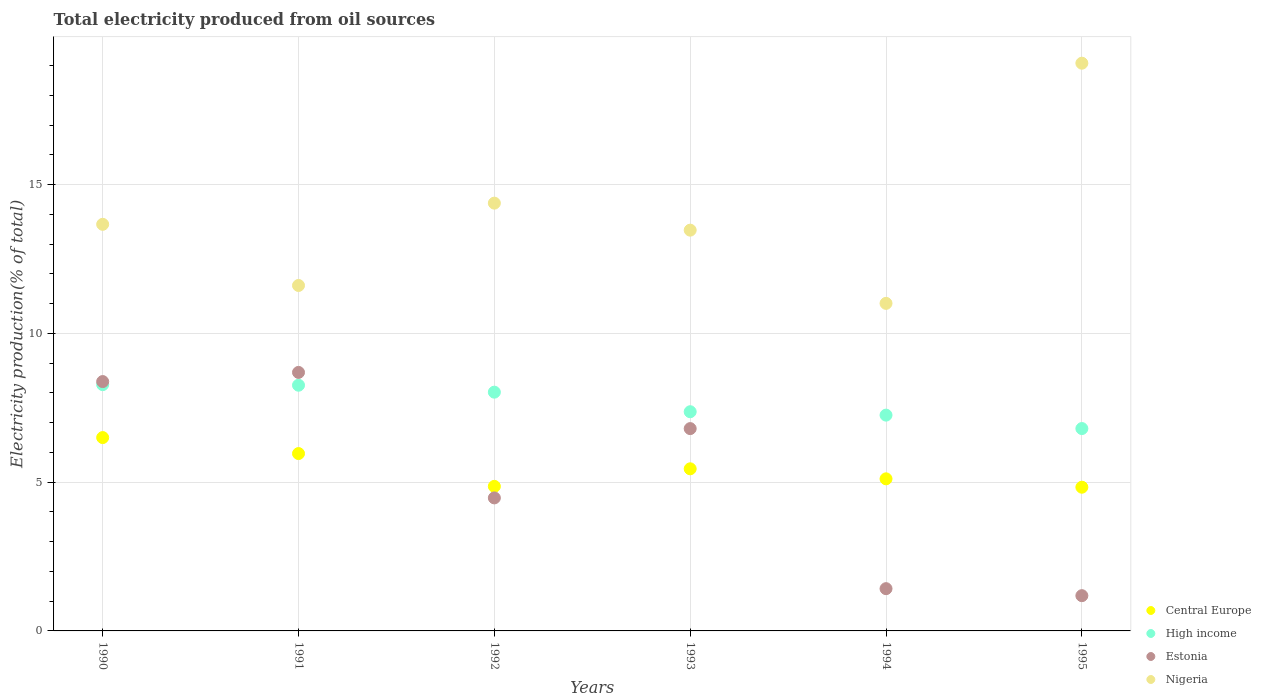Is the number of dotlines equal to the number of legend labels?
Make the answer very short. Yes. What is the total electricity produced in Estonia in 1993?
Make the answer very short. 6.8. Across all years, what is the maximum total electricity produced in Estonia?
Make the answer very short. 8.69. Across all years, what is the minimum total electricity produced in Nigeria?
Your response must be concise. 11.01. In which year was the total electricity produced in High income maximum?
Make the answer very short. 1990. What is the total total electricity produced in Central Europe in the graph?
Offer a very short reply. 32.71. What is the difference between the total electricity produced in Nigeria in 1992 and that in 1993?
Provide a succinct answer. 0.91. What is the difference between the total electricity produced in Estonia in 1992 and the total electricity produced in Nigeria in 1990?
Provide a short and direct response. -9.2. What is the average total electricity produced in High income per year?
Offer a terse response. 7.66. In the year 1993, what is the difference between the total electricity produced in High income and total electricity produced in Central Europe?
Offer a terse response. 1.92. What is the ratio of the total electricity produced in Estonia in 1992 to that in 1993?
Give a very brief answer. 0.66. Is the total electricity produced in Central Europe in 1992 less than that in 1995?
Offer a very short reply. No. What is the difference between the highest and the second highest total electricity produced in High income?
Offer a very short reply. 0.02. What is the difference between the highest and the lowest total electricity produced in High income?
Make the answer very short. 1.48. In how many years, is the total electricity produced in High income greater than the average total electricity produced in High income taken over all years?
Provide a succinct answer. 3. Is the sum of the total electricity produced in Central Europe in 1993 and 1995 greater than the maximum total electricity produced in High income across all years?
Provide a succinct answer. Yes. Does the total electricity produced in Estonia monotonically increase over the years?
Offer a terse response. No. How many dotlines are there?
Your answer should be very brief. 4. What is the difference between two consecutive major ticks on the Y-axis?
Provide a succinct answer. 5. Does the graph contain any zero values?
Your answer should be very brief. No. Where does the legend appear in the graph?
Provide a succinct answer. Bottom right. How many legend labels are there?
Offer a very short reply. 4. What is the title of the graph?
Provide a short and direct response. Total electricity produced from oil sources. What is the label or title of the X-axis?
Your response must be concise. Years. What is the Electricity production(% of total) in Central Europe in 1990?
Make the answer very short. 6.5. What is the Electricity production(% of total) in High income in 1990?
Your answer should be compact. 8.28. What is the Electricity production(% of total) in Estonia in 1990?
Offer a very short reply. 8.38. What is the Electricity production(% of total) of Nigeria in 1990?
Ensure brevity in your answer.  13.67. What is the Electricity production(% of total) in Central Europe in 1991?
Provide a succinct answer. 5.96. What is the Electricity production(% of total) of High income in 1991?
Your answer should be compact. 8.26. What is the Electricity production(% of total) of Estonia in 1991?
Give a very brief answer. 8.69. What is the Electricity production(% of total) of Nigeria in 1991?
Your response must be concise. 11.61. What is the Electricity production(% of total) in Central Europe in 1992?
Give a very brief answer. 4.86. What is the Electricity production(% of total) of High income in 1992?
Offer a very short reply. 8.03. What is the Electricity production(% of total) of Estonia in 1992?
Provide a succinct answer. 4.47. What is the Electricity production(% of total) of Nigeria in 1992?
Offer a terse response. 14.38. What is the Electricity production(% of total) in Central Europe in 1993?
Ensure brevity in your answer.  5.45. What is the Electricity production(% of total) of High income in 1993?
Offer a very short reply. 7.37. What is the Electricity production(% of total) of Estonia in 1993?
Keep it short and to the point. 6.8. What is the Electricity production(% of total) of Nigeria in 1993?
Keep it short and to the point. 13.47. What is the Electricity production(% of total) in Central Europe in 1994?
Keep it short and to the point. 5.11. What is the Electricity production(% of total) of High income in 1994?
Make the answer very short. 7.25. What is the Electricity production(% of total) in Estonia in 1994?
Your answer should be compact. 1.42. What is the Electricity production(% of total) in Nigeria in 1994?
Your answer should be very brief. 11.01. What is the Electricity production(% of total) in Central Europe in 1995?
Offer a terse response. 4.83. What is the Electricity production(% of total) in High income in 1995?
Your response must be concise. 6.8. What is the Electricity production(% of total) in Estonia in 1995?
Make the answer very short. 1.18. What is the Electricity production(% of total) of Nigeria in 1995?
Your answer should be compact. 19.08. Across all years, what is the maximum Electricity production(% of total) of Central Europe?
Give a very brief answer. 6.5. Across all years, what is the maximum Electricity production(% of total) in High income?
Offer a terse response. 8.28. Across all years, what is the maximum Electricity production(% of total) of Estonia?
Give a very brief answer. 8.69. Across all years, what is the maximum Electricity production(% of total) in Nigeria?
Your answer should be very brief. 19.08. Across all years, what is the minimum Electricity production(% of total) in Central Europe?
Offer a very short reply. 4.83. Across all years, what is the minimum Electricity production(% of total) in High income?
Ensure brevity in your answer.  6.8. Across all years, what is the minimum Electricity production(% of total) of Estonia?
Your response must be concise. 1.18. Across all years, what is the minimum Electricity production(% of total) of Nigeria?
Offer a terse response. 11.01. What is the total Electricity production(% of total) in Central Europe in the graph?
Offer a very short reply. 32.71. What is the total Electricity production(% of total) in High income in the graph?
Offer a very short reply. 45.99. What is the total Electricity production(% of total) of Estonia in the graph?
Ensure brevity in your answer.  30.95. What is the total Electricity production(% of total) of Nigeria in the graph?
Provide a succinct answer. 83.22. What is the difference between the Electricity production(% of total) of Central Europe in 1990 and that in 1991?
Keep it short and to the point. 0.54. What is the difference between the Electricity production(% of total) in High income in 1990 and that in 1991?
Offer a terse response. 0.02. What is the difference between the Electricity production(% of total) of Estonia in 1990 and that in 1991?
Your response must be concise. -0.31. What is the difference between the Electricity production(% of total) in Nigeria in 1990 and that in 1991?
Provide a succinct answer. 2.06. What is the difference between the Electricity production(% of total) in Central Europe in 1990 and that in 1992?
Keep it short and to the point. 1.64. What is the difference between the Electricity production(% of total) in High income in 1990 and that in 1992?
Your answer should be compact. 0.25. What is the difference between the Electricity production(% of total) in Estonia in 1990 and that in 1992?
Provide a short and direct response. 3.91. What is the difference between the Electricity production(% of total) in Nigeria in 1990 and that in 1992?
Keep it short and to the point. -0.71. What is the difference between the Electricity production(% of total) of Central Europe in 1990 and that in 1993?
Ensure brevity in your answer.  1.05. What is the difference between the Electricity production(% of total) in High income in 1990 and that in 1993?
Make the answer very short. 0.91. What is the difference between the Electricity production(% of total) of Estonia in 1990 and that in 1993?
Your response must be concise. 1.58. What is the difference between the Electricity production(% of total) of Nigeria in 1990 and that in 1993?
Your response must be concise. 0.2. What is the difference between the Electricity production(% of total) of Central Europe in 1990 and that in 1994?
Keep it short and to the point. 1.39. What is the difference between the Electricity production(% of total) of High income in 1990 and that in 1994?
Offer a very short reply. 1.03. What is the difference between the Electricity production(% of total) of Estonia in 1990 and that in 1994?
Ensure brevity in your answer.  6.96. What is the difference between the Electricity production(% of total) of Nigeria in 1990 and that in 1994?
Offer a very short reply. 2.66. What is the difference between the Electricity production(% of total) of Central Europe in 1990 and that in 1995?
Provide a succinct answer. 1.67. What is the difference between the Electricity production(% of total) of High income in 1990 and that in 1995?
Offer a very short reply. 1.48. What is the difference between the Electricity production(% of total) of Estonia in 1990 and that in 1995?
Provide a succinct answer. 7.2. What is the difference between the Electricity production(% of total) of Nigeria in 1990 and that in 1995?
Keep it short and to the point. -5.42. What is the difference between the Electricity production(% of total) of Central Europe in 1991 and that in 1992?
Provide a succinct answer. 1.1. What is the difference between the Electricity production(% of total) in High income in 1991 and that in 1992?
Provide a succinct answer. 0.23. What is the difference between the Electricity production(% of total) of Estonia in 1991 and that in 1992?
Your answer should be compact. 4.22. What is the difference between the Electricity production(% of total) of Nigeria in 1991 and that in 1992?
Make the answer very short. -2.77. What is the difference between the Electricity production(% of total) of Central Europe in 1991 and that in 1993?
Provide a short and direct response. 0.51. What is the difference between the Electricity production(% of total) in High income in 1991 and that in 1993?
Make the answer very short. 0.89. What is the difference between the Electricity production(% of total) of Estonia in 1991 and that in 1993?
Your answer should be compact. 1.89. What is the difference between the Electricity production(% of total) of Nigeria in 1991 and that in 1993?
Ensure brevity in your answer.  -1.86. What is the difference between the Electricity production(% of total) of Central Europe in 1991 and that in 1994?
Ensure brevity in your answer.  0.85. What is the difference between the Electricity production(% of total) of High income in 1991 and that in 1994?
Your response must be concise. 1.01. What is the difference between the Electricity production(% of total) of Estonia in 1991 and that in 1994?
Your answer should be very brief. 7.27. What is the difference between the Electricity production(% of total) of Nigeria in 1991 and that in 1994?
Offer a very short reply. 0.6. What is the difference between the Electricity production(% of total) of Central Europe in 1991 and that in 1995?
Provide a short and direct response. 1.13. What is the difference between the Electricity production(% of total) in High income in 1991 and that in 1995?
Your response must be concise. 1.46. What is the difference between the Electricity production(% of total) in Estonia in 1991 and that in 1995?
Ensure brevity in your answer.  7.5. What is the difference between the Electricity production(% of total) of Nigeria in 1991 and that in 1995?
Provide a succinct answer. -7.47. What is the difference between the Electricity production(% of total) of Central Europe in 1992 and that in 1993?
Ensure brevity in your answer.  -0.59. What is the difference between the Electricity production(% of total) of High income in 1992 and that in 1993?
Offer a terse response. 0.66. What is the difference between the Electricity production(% of total) in Estonia in 1992 and that in 1993?
Your answer should be compact. -2.33. What is the difference between the Electricity production(% of total) of Nigeria in 1992 and that in 1993?
Offer a very short reply. 0.91. What is the difference between the Electricity production(% of total) of Central Europe in 1992 and that in 1994?
Provide a succinct answer. -0.25. What is the difference between the Electricity production(% of total) in High income in 1992 and that in 1994?
Give a very brief answer. 0.77. What is the difference between the Electricity production(% of total) in Estonia in 1992 and that in 1994?
Keep it short and to the point. 3.05. What is the difference between the Electricity production(% of total) in Nigeria in 1992 and that in 1994?
Your answer should be compact. 3.37. What is the difference between the Electricity production(% of total) in Central Europe in 1992 and that in 1995?
Make the answer very short. 0.03. What is the difference between the Electricity production(% of total) in High income in 1992 and that in 1995?
Give a very brief answer. 1.22. What is the difference between the Electricity production(% of total) in Estonia in 1992 and that in 1995?
Your response must be concise. 3.29. What is the difference between the Electricity production(% of total) of Nigeria in 1992 and that in 1995?
Provide a succinct answer. -4.7. What is the difference between the Electricity production(% of total) in Central Europe in 1993 and that in 1994?
Provide a short and direct response. 0.34. What is the difference between the Electricity production(% of total) in High income in 1993 and that in 1994?
Provide a short and direct response. 0.11. What is the difference between the Electricity production(% of total) of Estonia in 1993 and that in 1994?
Your answer should be very brief. 5.38. What is the difference between the Electricity production(% of total) in Nigeria in 1993 and that in 1994?
Make the answer very short. 2.46. What is the difference between the Electricity production(% of total) in Central Europe in 1993 and that in 1995?
Ensure brevity in your answer.  0.62. What is the difference between the Electricity production(% of total) in High income in 1993 and that in 1995?
Keep it short and to the point. 0.57. What is the difference between the Electricity production(% of total) in Estonia in 1993 and that in 1995?
Make the answer very short. 5.62. What is the difference between the Electricity production(% of total) in Nigeria in 1993 and that in 1995?
Provide a short and direct response. -5.61. What is the difference between the Electricity production(% of total) in Central Europe in 1994 and that in 1995?
Your answer should be very brief. 0.28. What is the difference between the Electricity production(% of total) in High income in 1994 and that in 1995?
Your response must be concise. 0.45. What is the difference between the Electricity production(% of total) of Estonia in 1994 and that in 1995?
Keep it short and to the point. 0.24. What is the difference between the Electricity production(% of total) of Nigeria in 1994 and that in 1995?
Ensure brevity in your answer.  -8.07. What is the difference between the Electricity production(% of total) in Central Europe in 1990 and the Electricity production(% of total) in High income in 1991?
Provide a succinct answer. -1.76. What is the difference between the Electricity production(% of total) of Central Europe in 1990 and the Electricity production(% of total) of Estonia in 1991?
Ensure brevity in your answer.  -2.19. What is the difference between the Electricity production(% of total) in Central Europe in 1990 and the Electricity production(% of total) in Nigeria in 1991?
Your answer should be compact. -5.11. What is the difference between the Electricity production(% of total) in High income in 1990 and the Electricity production(% of total) in Estonia in 1991?
Your response must be concise. -0.41. What is the difference between the Electricity production(% of total) in High income in 1990 and the Electricity production(% of total) in Nigeria in 1991?
Your response must be concise. -3.33. What is the difference between the Electricity production(% of total) in Estonia in 1990 and the Electricity production(% of total) in Nigeria in 1991?
Provide a succinct answer. -3.23. What is the difference between the Electricity production(% of total) in Central Europe in 1990 and the Electricity production(% of total) in High income in 1992?
Your answer should be compact. -1.53. What is the difference between the Electricity production(% of total) of Central Europe in 1990 and the Electricity production(% of total) of Estonia in 1992?
Offer a very short reply. 2.03. What is the difference between the Electricity production(% of total) in Central Europe in 1990 and the Electricity production(% of total) in Nigeria in 1992?
Give a very brief answer. -7.88. What is the difference between the Electricity production(% of total) in High income in 1990 and the Electricity production(% of total) in Estonia in 1992?
Keep it short and to the point. 3.81. What is the difference between the Electricity production(% of total) of High income in 1990 and the Electricity production(% of total) of Nigeria in 1992?
Your response must be concise. -6.1. What is the difference between the Electricity production(% of total) of Estonia in 1990 and the Electricity production(% of total) of Nigeria in 1992?
Make the answer very short. -6. What is the difference between the Electricity production(% of total) of Central Europe in 1990 and the Electricity production(% of total) of High income in 1993?
Offer a very short reply. -0.87. What is the difference between the Electricity production(% of total) of Central Europe in 1990 and the Electricity production(% of total) of Estonia in 1993?
Offer a very short reply. -0.3. What is the difference between the Electricity production(% of total) in Central Europe in 1990 and the Electricity production(% of total) in Nigeria in 1993?
Give a very brief answer. -6.97. What is the difference between the Electricity production(% of total) in High income in 1990 and the Electricity production(% of total) in Estonia in 1993?
Your response must be concise. 1.48. What is the difference between the Electricity production(% of total) of High income in 1990 and the Electricity production(% of total) of Nigeria in 1993?
Provide a short and direct response. -5.19. What is the difference between the Electricity production(% of total) in Estonia in 1990 and the Electricity production(% of total) in Nigeria in 1993?
Make the answer very short. -5.09. What is the difference between the Electricity production(% of total) in Central Europe in 1990 and the Electricity production(% of total) in High income in 1994?
Your answer should be very brief. -0.75. What is the difference between the Electricity production(% of total) in Central Europe in 1990 and the Electricity production(% of total) in Estonia in 1994?
Provide a short and direct response. 5.08. What is the difference between the Electricity production(% of total) in Central Europe in 1990 and the Electricity production(% of total) in Nigeria in 1994?
Make the answer very short. -4.51. What is the difference between the Electricity production(% of total) of High income in 1990 and the Electricity production(% of total) of Estonia in 1994?
Provide a succinct answer. 6.86. What is the difference between the Electricity production(% of total) of High income in 1990 and the Electricity production(% of total) of Nigeria in 1994?
Offer a very short reply. -2.73. What is the difference between the Electricity production(% of total) of Estonia in 1990 and the Electricity production(% of total) of Nigeria in 1994?
Offer a very short reply. -2.63. What is the difference between the Electricity production(% of total) of Central Europe in 1990 and the Electricity production(% of total) of High income in 1995?
Provide a short and direct response. -0.3. What is the difference between the Electricity production(% of total) in Central Europe in 1990 and the Electricity production(% of total) in Estonia in 1995?
Give a very brief answer. 5.31. What is the difference between the Electricity production(% of total) of Central Europe in 1990 and the Electricity production(% of total) of Nigeria in 1995?
Give a very brief answer. -12.58. What is the difference between the Electricity production(% of total) in High income in 1990 and the Electricity production(% of total) in Estonia in 1995?
Offer a very short reply. 7.09. What is the difference between the Electricity production(% of total) of High income in 1990 and the Electricity production(% of total) of Nigeria in 1995?
Your answer should be very brief. -10.8. What is the difference between the Electricity production(% of total) in Estonia in 1990 and the Electricity production(% of total) in Nigeria in 1995?
Offer a very short reply. -10.7. What is the difference between the Electricity production(% of total) in Central Europe in 1991 and the Electricity production(% of total) in High income in 1992?
Keep it short and to the point. -2.06. What is the difference between the Electricity production(% of total) of Central Europe in 1991 and the Electricity production(% of total) of Estonia in 1992?
Offer a very short reply. 1.49. What is the difference between the Electricity production(% of total) of Central Europe in 1991 and the Electricity production(% of total) of Nigeria in 1992?
Offer a terse response. -8.42. What is the difference between the Electricity production(% of total) of High income in 1991 and the Electricity production(% of total) of Estonia in 1992?
Provide a short and direct response. 3.79. What is the difference between the Electricity production(% of total) in High income in 1991 and the Electricity production(% of total) in Nigeria in 1992?
Your response must be concise. -6.12. What is the difference between the Electricity production(% of total) in Estonia in 1991 and the Electricity production(% of total) in Nigeria in 1992?
Offer a terse response. -5.69. What is the difference between the Electricity production(% of total) of Central Europe in 1991 and the Electricity production(% of total) of High income in 1993?
Make the answer very short. -1.41. What is the difference between the Electricity production(% of total) in Central Europe in 1991 and the Electricity production(% of total) in Estonia in 1993?
Provide a short and direct response. -0.84. What is the difference between the Electricity production(% of total) of Central Europe in 1991 and the Electricity production(% of total) of Nigeria in 1993?
Provide a succinct answer. -7.51. What is the difference between the Electricity production(% of total) in High income in 1991 and the Electricity production(% of total) in Estonia in 1993?
Your answer should be very brief. 1.46. What is the difference between the Electricity production(% of total) of High income in 1991 and the Electricity production(% of total) of Nigeria in 1993?
Provide a succinct answer. -5.21. What is the difference between the Electricity production(% of total) of Estonia in 1991 and the Electricity production(% of total) of Nigeria in 1993?
Provide a short and direct response. -4.78. What is the difference between the Electricity production(% of total) of Central Europe in 1991 and the Electricity production(% of total) of High income in 1994?
Provide a succinct answer. -1.29. What is the difference between the Electricity production(% of total) in Central Europe in 1991 and the Electricity production(% of total) in Estonia in 1994?
Make the answer very short. 4.54. What is the difference between the Electricity production(% of total) of Central Europe in 1991 and the Electricity production(% of total) of Nigeria in 1994?
Your answer should be compact. -5.05. What is the difference between the Electricity production(% of total) of High income in 1991 and the Electricity production(% of total) of Estonia in 1994?
Provide a succinct answer. 6.84. What is the difference between the Electricity production(% of total) in High income in 1991 and the Electricity production(% of total) in Nigeria in 1994?
Keep it short and to the point. -2.75. What is the difference between the Electricity production(% of total) in Estonia in 1991 and the Electricity production(% of total) in Nigeria in 1994?
Provide a short and direct response. -2.32. What is the difference between the Electricity production(% of total) in Central Europe in 1991 and the Electricity production(% of total) in High income in 1995?
Offer a terse response. -0.84. What is the difference between the Electricity production(% of total) in Central Europe in 1991 and the Electricity production(% of total) in Estonia in 1995?
Offer a terse response. 4.78. What is the difference between the Electricity production(% of total) in Central Europe in 1991 and the Electricity production(% of total) in Nigeria in 1995?
Ensure brevity in your answer.  -13.12. What is the difference between the Electricity production(% of total) of High income in 1991 and the Electricity production(% of total) of Estonia in 1995?
Keep it short and to the point. 7.07. What is the difference between the Electricity production(% of total) of High income in 1991 and the Electricity production(% of total) of Nigeria in 1995?
Offer a terse response. -10.82. What is the difference between the Electricity production(% of total) of Estonia in 1991 and the Electricity production(% of total) of Nigeria in 1995?
Make the answer very short. -10.39. What is the difference between the Electricity production(% of total) of Central Europe in 1992 and the Electricity production(% of total) of High income in 1993?
Ensure brevity in your answer.  -2.51. What is the difference between the Electricity production(% of total) in Central Europe in 1992 and the Electricity production(% of total) in Estonia in 1993?
Offer a terse response. -1.94. What is the difference between the Electricity production(% of total) in Central Europe in 1992 and the Electricity production(% of total) in Nigeria in 1993?
Make the answer very short. -8.61. What is the difference between the Electricity production(% of total) in High income in 1992 and the Electricity production(% of total) in Estonia in 1993?
Give a very brief answer. 1.22. What is the difference between the Electricity production(% of total) in High income in 1992 and the Electricity production(% of total) in Nigeria in 1993?
Keep it short and to the point. -5.45. What is the difference between the Electricity production(% of total) of Estonia in 1992 and the Electricity production(% of total) of Nigeria in 1993?
Offer a very short reply. -9. What is the difference between the Electricity production(% of total) of Central Europe in 1992 and the Electricity production(% of total) of High income in 1994?
Provide a succinct answer. -2.39. What is the difference between the Electricity production(% of total) in Central Europe in 1992 and the Electricity production(% of total) in Estonia in 1994?
Provide a short and direct response. 3.44. What is the difference between the Electricity production(% of total) in Central Europe in 1992 and the Electricity production(% of total) in Nigeria in 1994?
Your answer should be compact. -6.15. What is the difference between the Electricity production(% of total) in High income in 1992 and the Electricity production(% of total) in Estonia in 1994?
Your answer should be compact. 6.6. What is the difference between the Electricity production(% of total) in High income in 1992 and the Electricity production(% of total) in Nigeria in 1994?
Make the answer very short. -2.98. What is the difference between the Electricity production(% of total) in Estonia in 1992 and the Electricity production(% of total) in Nigeria in 1994?
Offer a terse response. -6.54. What is the difference between the Electricity production(% of total) in Central Europe in 1992 and the Electricity production(% of total) in High income in 1995?
Your response must be concise. -1.94. What is the difference between the Electricity production(% of total) of Central Europe in 1992 and the Electricity production(% of total) of Estonia in 1995?
Provide a succinct answer. 3.67. What is the difference between the Electricity production(% of total) in Central Europe in 1992 and the Electricity production(% of total) in Nigeria in 1995?
Keep it short and to the point. -14.22. What is the difference between the Electricity production(% of total) in High income in 1992 and the Electricity production(% of total) in Estonia in 1995?
Make the answer very short. 6.84. What is the difference between the Electricity production(% of total) in High income in 1992 and the Electricity production(% of total) in Nigeria in 1995?
Your answer should be compact. -11.06. What is the difference between the Electricity production(% of total) in Estonia in 1992 and the Electricity production(% of total) in Nigeria in 1995?
Your answer should be very brief. -14.61. What is the difference between the Electricity production(% of total) in Central Europe in 1993 and the Electricity production(% of total) in High income in 1994?
Offer a terse response. -1.8. What is the difference between the Electricity production(% of total) in Central Europe in 1993 and the Electricity production(% of total) in Estonia in 1994?
Provide a succinct answer. 4.03. What is the difference between the Electricity production(% of total) of Central Europe in 1993 and the Electricity production(% of total) of Nigeria in 1994?
Your answer should be compact. -5.56. What is the difference between the Electricity production(% of total) in High income in 1993 and the Electricity production(% of total) in Estonia in 1994?
Provide a succinct answer. 5.95. What is the difference between the Electricity production(% of total) of High income in 1993 and the Electricity production(% of total) of Nigeria in 1994?
Give a very brief answer. -3.64. What is the difference between the Electricity production(% of total) in Estonia in 1993 and the Electricity production(% of total) in Nigeria in 1994?
Offer a terse response. -4.21. What is the difference between the Electricity production(% of total) in Central Europe in 1993 and the Electricity production(% of total) in High income in 1995?
Offer a very short reply. -1.35. What is the difference between the Electricity production(% of total) of Central Europe in 1993 and the Electricity production(% of total) of Estonia in 1995?
Provide a succinct answer. 4.26. What is the difference between the Electricity production(% of total) in Central Europe in 1993 and the Electricity production(% of total) in Nigeria in 1995?
Your response must be concise. -13.63. What is the difference between the Electricity production(% of total) in High income in 1993 and the Electricity production(% of total) in Estonia in 1995?
Offer a terse response. 6.18. What is the difference between the Electricity production(% of total) of High income in 1993 and the Electricity production(% of total) of Nigeria in 1995?
Your answer should be very brief. -11.72. What is the difference between the Electricity production(% of total) of Estonia in 1993 and the Electricity production(% of total) of Nigeria in 1995?
Your answer should be very brief. -12.28. What is the difference between the Electricity production(% of total) in Central Europe in 1994 and the Electricity production(% of total) in High income in 1995?
Make the answer very short. -1.69. What is the difference between the Electricity production(% of total) of Central Europe in 1994 and the Electricity production(% of total) of Estonia in 1995?
Ensure brevity in your answer.  3.93. What is the difference between the Electricity production(% of total) in Central Europe in 1994 and the Electricity production(% of total) in Nigeria in 1995?
Give a very brief answer. -13.97. What is the difference between the Electricity production(% of total) in High income in 1994 and the Electricity production(% of total) in Estonia in 1995?
Ensure brevity in your answer.  6.07. What is the difference between the Electricity production(% of total) of High income in 1994 and the Electricity production(% of total) of Nigeria in 1995?
Give a very brief answer. -11.83. What is the difference between the Electricity production(% of total) in Estonia in 1994 and the Electricity production(% of total) in Nigeria in 1995?
Ensure brevity in your answer.  -17.66. What is the average Electricity production(% of total) of Central Europe per year?
Offer a terse response. 5.45. What is the average Electricity production(% of total) of High income per year?
Offer a very short reply. 7.66. What is the average Electricity production(% of total) of Estonia per year?
Provide a short and direct response. 5.16. What is the average Electricity production(% of total) in Nigeria per year?
Ensure brevity in your answer.  13.87. In the year 1990, what is the difference between the Electricity production(% of total) of Central Europe and Electricity production(% of total) of High income?
Make the answer very short. -1.78. In the year 1990, what is the difference between the Electricity production(% of total) in Central Europe and Electricity production(% of total) in Estonia?
Your response must be concise. -1.88. In the year 1990, what is the difference between the Electricity production(% of total) in Central Europe and Electricity production(% of total) in Nigeria?
Your response must be concise. -7.17. In the year 1990, what is the difference between the Electricity production(% of total) in High income and Electricity production(% of total) in Estonia?
Your answer should be very brief. -0.1. In the year 1990, what is the difference between the Electricity production(% of total) of High income and Electricity production(% of total) of Nigeria?
Give a very brief answer. -5.39. In the year 1990, what is the difference between the Electricity production(% of total) of Estonia and Electricity production(% of total) of Nigeria?
Provide a succinct answer. -5.29. In the year 1991, what is the difference between the Electricity production(% of total) of Central Europe and Electricity production(% of total) of High income?
Offer a terse response. -2.3. In the year 1991, what is the difference between the Electricity production(% of total) in Central Europe and Electricity production(% of total) in Estonia?
Keep it short and to the point. -2.73. In the year 1991, what is the difference between the Electricity production(% of total) of Central Europe and Electricity production(% of total) of Nigeria?
Offer a very short reply. -5.65. In the year 1991, what is the difference between the Electricity production(% of total) of High income and Electricity production(% of total) of Estonia?
Your answer should be compact. -0.43. In the year 1991, what is the difference between the Electricity production(% of total) of High income and Electricity production(% of total) of Nigeria?
Offer a very short reply. -3.35. In the year 1991, what is the difference between the Electricity production(% of total) of Estonia and Electricity production(% of total) of Nigeria?
Give a very brief answer. -2.92. In the year 1992, what is the difference between the Electricity production(% of total) of Central Europe and Electricity production(% of total) of High income?
Offer a very short reply. -3.17. In the year 1992, what is the difference between the Electricity production(% of total) of Central Europe and Electricity production(% of total) of Estonia?
Ensure brevity in your answer.  0.39. In the year 1992, what is the difference between the Electricity production(% of total) of Central Europe and Electricity production(% of total) of Nigeria?
Make the answer very short. -9.52. In the year 1992, what is the difference between the Electricity production(% of total) of High income and Electricity production(% of total) of Estonia?
Your response must be concise. 3.55. In the year 1992, what is the difference between the Electricity production(% of total) in High income and Electricity production(% of total) in Nigeria?
Provide a succinct answer. -6.35. In the year 1992, what is the difference between the Electricity production(% of total) in Estonia and Electricity production(% of total) in Nigeria?
Ensure brevity in your answer.  -9.91. In the year 1993, what is the difference between the Electricity production(% of total) of Central Europe and Electricity production(% of total) of High income?
Provide a short and direct response. -1.92. In the year 1993, what is the difference between the Electricity production(% of total) in Central Europe and Electricity production(% of total) in Estonia?
Offer a terse response. -1.35. In the year 1993, what is the difference between the Electricity production(% of total) of Central Europe and Electricity production(% of total) of Nigeria?
Offer a terse response. -8.02. In the year 1993, what is the difference between the Electricity production(% of total) in High income and Electricity production(% of total) in Estonia?
Offer a terse response. 0.57. In the year 1993, what is the difference between the Electricity production(% of total) in High income and Electricity production(% of total) in Nigeria?
Provide a succinct answer. -6.1. In the year 1993, what is the difference between the Electricity production(% of total) in Estonia and Electricity production(% of total) in Nigeria?
Give a very brief answer. -6.67. In the year 1994, what is the difference between the Electricity production(% of total) of Central Europe and Electricity production(% of total) of High income?
Provide a short and direct response. -2.14. In the year 1994, what is the difference between the Electricity production(% of total) of Central Europe and Electricity production(% of total) of Estonia?
Provide a short and direct response. 3.69. In the year 1994, what is the difference between the Electricity production(% of total) in Central Europe and Electricity production(% of total) in Nigeria?
Give a very brief answer. -5.9. In the year 1994, what is the difference between the Electricity production(% of total) in High income and Electricity production(% of total) in Estonia?
Provide a short and direct response. 5.83. In the year 1994, what is the difference between the Electricity production(% of total) in High income and Electricity production(% of total) in Nigeria?
Your answer should be very brief. -3.76. In the year 1994, what is the difference between the Electricity production(% of total) in Estonia and Electricity production(% of total) in Nigeria?
Provide a succinct answer. -9.59. In the year 1995, what is the difference between the Electricity production(% of total) in Central Europe and Electricity production(% of total) in High income?
Offer a terse response. -1.97. In the year 1995, what is the difference between the Electricity production(% of total) in Central Europe and Electricity production(% of total) in Estonia?
Provide a short and direct response. 3.65. In the year 1995, what is the difference between the Electricity production(% of total) of Central Europe and Electricity production(% of total) of Nigeria?
Make the answer very short. -14.25. In the year 1995, what is the difference between the Electricity production(% of total) of High income and Electricity production(% of total) of Estonia?
Keep it short and to the point. 5.62. In the year 1995, what is the difference between the Electricity production(% of total) of High income and Electricity production(% of total) of Nigeria?
Your answer should be very brief. -12.28. In the year 1995, what is the difference between the Electricity production(% of total) of Estonia and Electricity production(% of total) of Nigeria?
Give a very brief answer. -17.9. What is the ratio of the Electricity production(% of total) in Central Europe in 1990 to that in 1991?
Your response must be concise. 1.09. What is the ratio of the Electricity production(% of total) of High income in 1990 to that in 1991?
Your response must be concise. 1. What is the ratio of the Electricity production(% of total) in Estonia in 1990 to that in 1991?
Give a very brief answer. 0.96. What is the ratio of the Electricity production(% of total) in Nigeria in 1990 to that in 1991?
Provide a short and direct response. 1.18. What is the ratio of the Electricity production(% of total) of Central Europe in 1990 to that in 1992?
Make the answer very short. 1.34. What is the ratio of the Electricity production(% of total) in High income in 1990 to that in 1992?
Ensure brevity in your answer.  1.03. What is the ratio of the Electricity production(% of total) in Estonia in 1990 to that in 1992?
Your answer should be compact. 1.87. What is the ratio of the Electricity production(% of total) of Nigeria in 1990 to that in 1992?
Offer a terse response. 0.95. What is the ratio of the Electricity production(% of total) in Central Europe in 1990 to that in 1993?
Your answer should be compact. 1.19. What is the ratio of the Electricity production(% of total) in High income in 1990 to that in 1993?
Make the answer very short. 1.12. What is the ratio of the Electricity production(% of total) in Estonia in 1990 to that in 1993?
Make the answer very short. 1.23. What is the ratio of the Electricity production(% of total) in Nigeria in 1990 to that in 1993?
Provide a short and direct response. 1.01. What is the ratio of the Electricity production(% of total) of Central Europe in 1990 to that in 1994?
Your response must be concise. 1.27. What is the ratio of the Electricity production(% of total) in High income in 1990 to that in 1994?
Give a very brief answer. 1.14. What is the ratio of the Electricity production(% of total) in Estonia in 1990 to that in 1994?
Keep it short and to the point. 5.9. What is the ratio of the Electricity production(% of total) of Nigeria in 1990 to that in 1994?
Give a very brief answer. 1.24. What is the ratio of the Electricity production(% of total) in Central Europe in 1990 to that in 1995?
Provide a succinct answer. 1.35. What is the ratio of the Electricity production(% of total) in High income in 1990 to that in 1995?
Provide a succinct answer. 1.22. What is the ratio of the Electricity production(% of total) in Estonia in 1990 to that in 1995?
Your answer should be very brief. 7.07. What is the ratio of the Electricity production(% of total) of Nigeria in 1990 to that in 1995?
Provide a succinct answer. 0.72. What is the ratio of the Electricity production(% of total) of Central Europe in 1991 to that in 1992?
Give a very brief answer. 1.23. What is the ratio of the Electricity production(% of total) in High income in 1991 to that in 1992?
Offer a terse response. 1.03. What is the ratio of the Electricity production(% of total) of Estonia in 1991 to that in 1992?
Keep it short and to the point. 1.94. What is the ratio of the Electricity production(% of total) of Nigeria in 1991 to that in 1992?
Provide a short and direct response. 0.81. What is the ratio of the Electricity production(% of total) in Central Europe in 1991 to that in 1993?
Make the answer very short. 1.09. What is the ratio of the Electricity production(% of total) of High income in 1991 to that in 1993?
Ensure brevity in your answer.  1.12. What is the ratio of the Electricity production(% of total) in Estonia in 1991 to that in 1993?
Offer a terse response. 1.28. What is the ratio of the Electricity production(% of total) of Nigeria in 1991 to that in 1993?
Give a very brief answer. 0.86. What is the ratio of the Electricity production(% of total) of Central Europe in 1991 to that in 1994?
Give a very brief answer. 1.17. What is the ratio of the Electricity production(% of total) in High income in 1991 to that in 1994?
Ensure brevity in your answer.  1.14. What is the ratio of the Electricity production(% of total) in Estonia in 1991 to that in 1994?
Make the answer very short. 6.12. What is the ratio of the Electricity production(% of total) of Nigeria in 1991 to that in 1994?
Provide a succinct answer. 1.05. What is the ratio of the Electricity production(% of total) of Central Europe in 1991 to that in 1995?
Ensure brevity in your answer.  1.23. What is the ratio of the Electricity production(% of total) in High income in 1991 to that in 1995?
Offer a very short reply. 1.21. What is the ratio of the Electricity production(% of total) of Estonia in 1991 to that in 1995?
Your answer should be compact. 7.33. What is the ratio of the Electricity production(% of total) in Nigeria in 1991 to that in 1995?
Offer a terse response. 0.61. What is the ratio of the Electricity production(% of total) of Central Europe in 1992 to that in 1993?
Your answer should be compact. 0.89. What is the ratio of the Electricity production(% of total) of High income in 1992 to that in 1993?
Make the answer very short. 1.09. What is the ratio of the Electricity production(% of total) in Estonia in 1992 to that in 1993?
Provide a succinct answer. 0.66. What is the ratio of the Electricity production(% of total) of Nigeria in 1992 to that in 1993?
Offer a terse response. 1.07. What is the ratio of the Electricity production(% of total) of Central Europe in 1992 to that in 1994?
Your answer should be compact. 0.95. What is the ratio of the Electricity production(% of total) in High income in 1992 to that in 1994?
Give a very brief answer. 1.11. What is the ratio of the Electricity production(% of total) of Estonia in 1992 to that in 1994?
Your answer should be compact. 3.15. What is the ratio of the Electricity production(% of total) of Nigeria in 1992 to that in 1994?
Give a very brief answer. 1.31. What is the ratio of the Electricity production(% of total) of High income in 1992 to that in 1995?
Keep it short and to the point. 1.18. What is the ratio of the Electricity production(% of total) of Estonia in 1992 to that in 1995?
Your response must be concise. 3.77. What is the ratio of the Electricity production(% of total) in Nigeria in 1992 to that in 1995?
Provide a succinct answer. 0.75. What is the ratio of the Electricity production(% of total) in Central Europe in 1993 to that in 1994?
Give a very brief answer. 1.07. What is the ratio of the Electricity production(% of total) in High income in 1993 to that in 1994?
Provide a succinct answer. 1.02. What is the ratio of the Electricity production(% of total) of Estonia in 1993 to that in 1994?
Provide a succinct answer. 4.79. What is the ratio of the Electricity production(% of total) in Nigeria in 1993 to that in 1994?
Your answer should be very brief. 1.22. What is the ratio of the Electricity production(% of total) in Central Europe in 1993 to that in 1995?
Offer a very short reply. 1.13. What is the ratio of the Electricity production(% of total) in High income in 1993 to that in 1995?
Provide a succinct answer. 1.08. What is the ratio of the Electricity production(% of total) in Estonia in 1993 to that in 1995?
Give a very brief answer. 5.74. What is the ratio of the Electricity production(% of total) of Nigeria in 1993 to that in 1995?
Give a very brief answer. 0.71. What is the ratio of the Electricity production(% of total) in Central Europe in 1994 to that in 1995?
Your answer should be very brief. 1.06. What is the ratio of the Electricity production(% of total) in High income in 1994 to that in 1995?
Offer a very short reply. 1.07. What is the ratio of the Electricity production(% of total) of Estonia in 1994 to that in 1995?
Your answer should be very brief. 1.2. What is the ratio of the Electricity production(% of total) of Nigeria in 1994 to that in 1995?
Offer a very short reply. 0.58. What is the difference between the highest and the second highest Electricity production(% of total) of Central Europe?
Offer a terse response. 0.54. What is the difference between the highest and the second highest Electricity production(% of total) in High income?
Keep it short and to the point. 0.02. What is the difference between the highest and the second highest Electricity production(% of total) in Estonia?
Ensure brevity in your answer.  0.31. What is the difference between the highest and the second highest Electricity production(% of total) of Nigeria?
Offer a very short reply. 4.7. What is the difference between the highest and the lowest Electricity production(% of total) of Central Europe?
Your answer should be very brief. 1.67. What is the difference between the highest and the lowest Electricity production(% of total) of High income?
Your answer should be very brief. 1.48. What is the difference between the highest and the lowest Electricity production(% of total) of Estonia?
Offer a very short reply. 7.5. What is the difference between the highest and the lowest Electricity production(% of total) in Nigeria?
Offer a terse response. 8.07. 